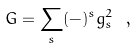<formula> <loc_0><loc_0><loc_500><loc_500>G = \sum _ { s } ( - ) ^ { s } g ^ { 2 } _ { s } \ ,</formula> 